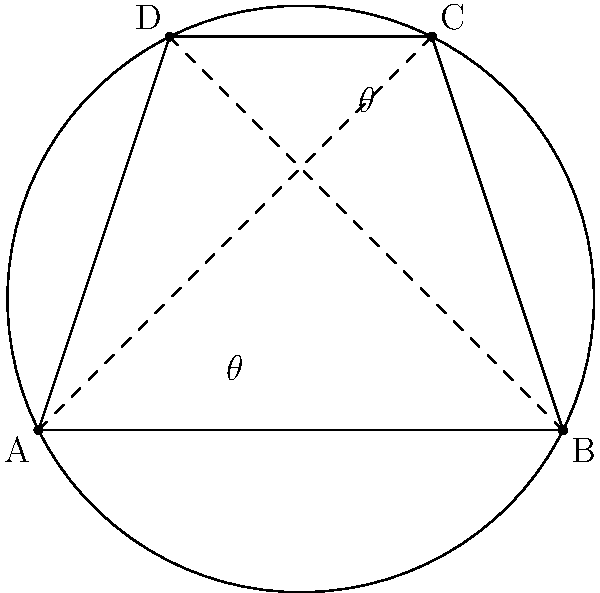In the cyclic quadrilateral ABCD, diagonal AC intersects diagonal BD at point E. Angle BAD is labeled as $\theta$. Prove that angle BCD is also equal to $\theta$, and explain how this property relates to Thales' theorem, an important concept in ancient Greek geometry. Let's approach this step-by-step:

1) In a cyclic quadrilateral, opposite angles are supplementary. This means:
   $$\angle BAD + \angle BCD = 180°$$
   $$\angle ABC + \angle ADC = 180°$$

2) The inscribed angle theorem states that an angle inscribed in a circle is half the central angle subtending the same arc. This means:
   $$\angle BAD = \frac{1}{2}\angle BCD$$
   $$\angle BCD = \frac{1}{2}\angle BAD$$

3) Let $\angle BAD = \theta$. Then from step 2:
   $$\angle BCD = \frac{1}{2}(180° - \theta) = 90° - \frac{\theta}{2}$$

4) But we also know from step 2 that:
   $$\angle BCD = \frac{1}{2}(180° - \theta) = 90° - \frac{\theta}{2} = \theta$$

5) Therefore, $\angle BAD = \angle BCD = \theta$

6) This property is closely related to Thales' theorem, which states that any triangle inscribed in a semicircle is a right triangle. In our case, if we consider the diameter of the circle as AC, then triangle ABC is inscribed in a semicircle, making $\angle ABC$ a right angle.

7) Thales' theorem is a special case of the inscribed angle theorem, where the inscribed angle is 90°. This connection demonstrates how the properties of cyclic quadrilaterals are fundamental to many ancient geometric proofs.
Answer: $\angle BAD = \angle BCD = \theta$ due to the inscribed angle theorem, relating to Thales' theorem as a special case. 